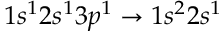Convert formula to latex. <formula><loc_0><loc_0><loc_500><loc_500>1 s ^ { 1 } 2 s ^ { 1 } 3 p ^ { 1 } \rightarrow 1 s ^ { 2 } 2 s ^ { 1 }</formula> 